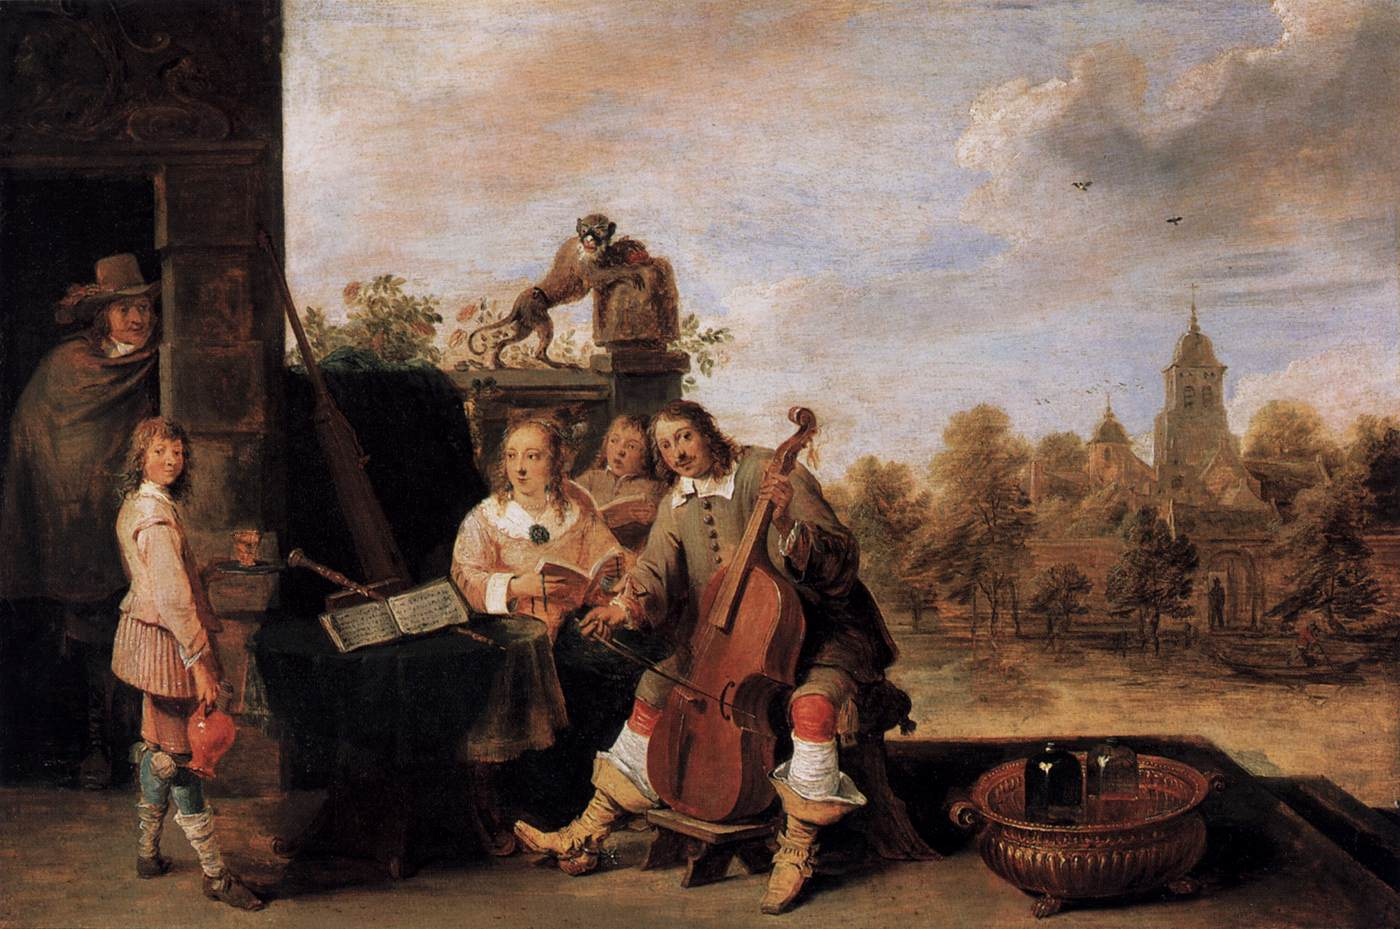Could you tell me more about the clothing worn by the figures? Certainly. The figures in the painting are clad in attire typical of European fashion from the 17th to the early 18th century, suggestive of a period where social status and profession were often depicted through clothing. The man playing the cello, for instance, wears breeches and stockings capped with ribboned garters, attire that was common amongst the bourgeois and artist classes. The woman's dress is layered and full, suggesting modesty and femininity, while the fabrics indicate she may be of a higher social standing. Lastly, the young boy is dressed in a simplified version of adult male attire, which was customary for children of the era. 